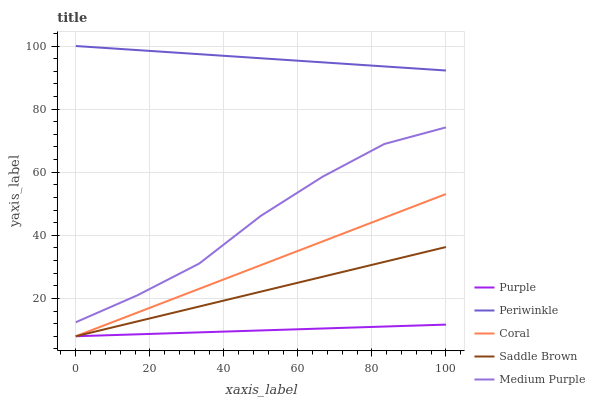Does Purple have the minimum area under the curve?
Answer yes or no. Yes. Does Periwinkle have the maximum area under the curve?
Answer yes or no. Yes. Does Medium Purple have the minimum area under the curve?
Answer yes or no. No. Does Medium Purple have the maximum area under the curve?
Answer yes or no. No. Is Purple the smoothest?
Answer yes or no. Yes. Is Medium Purple the roughest?
Answer yes or no. Yes. Is Coral the smoothest?
Answer yes or no. No. Is Coral the roughest?
Answer yes or no. No. Does Medium Purple have the lowest value?
Answer yes or no. No. Does Medium Purple have the highest value?
Answer yes or no. No. Is Saddle Brown less than Medium Purple?
Answer yes or no. Yes. Is Periwinkle greater than Coral?
Answer yes or no. Yes. Does Saddle Brown intersect Medium Purple?
Answer yes or no. No. 